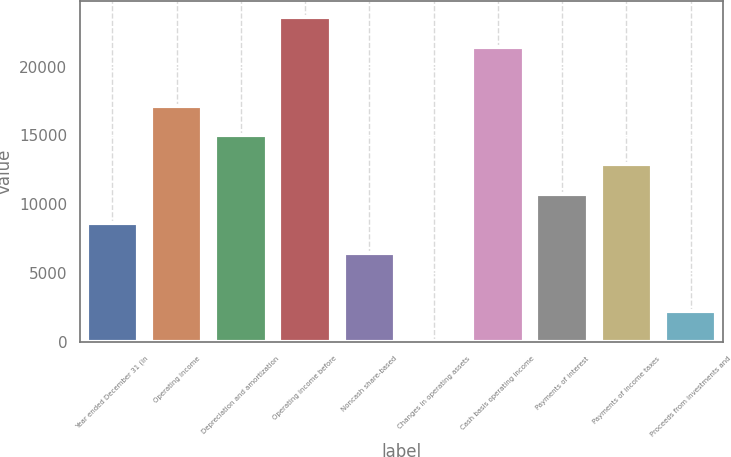<chart> <loc_0><loc_0><loc_500><loc_500><bar_chart><fcel>Year ended December 31 (in<fcel>Operating income<fcel>Depreciation and amortization<fcel>Operating income before<fcel>Noncash share-based<fcel>Changes in operating assets<fcel>Cash basis operating income<fcel>Payments of interest<fcel>Payments of income taxes<fcel>Proceeds from investments and<nl><fcel>8629.4<fcel>17165.8<fcel>15031.7<fcel>23568.1<fcel>6495.3<fcel>93<fcel>21434<fcel>10763.5<fcel>12897.6<fcel>2227.1<nl></chart> 